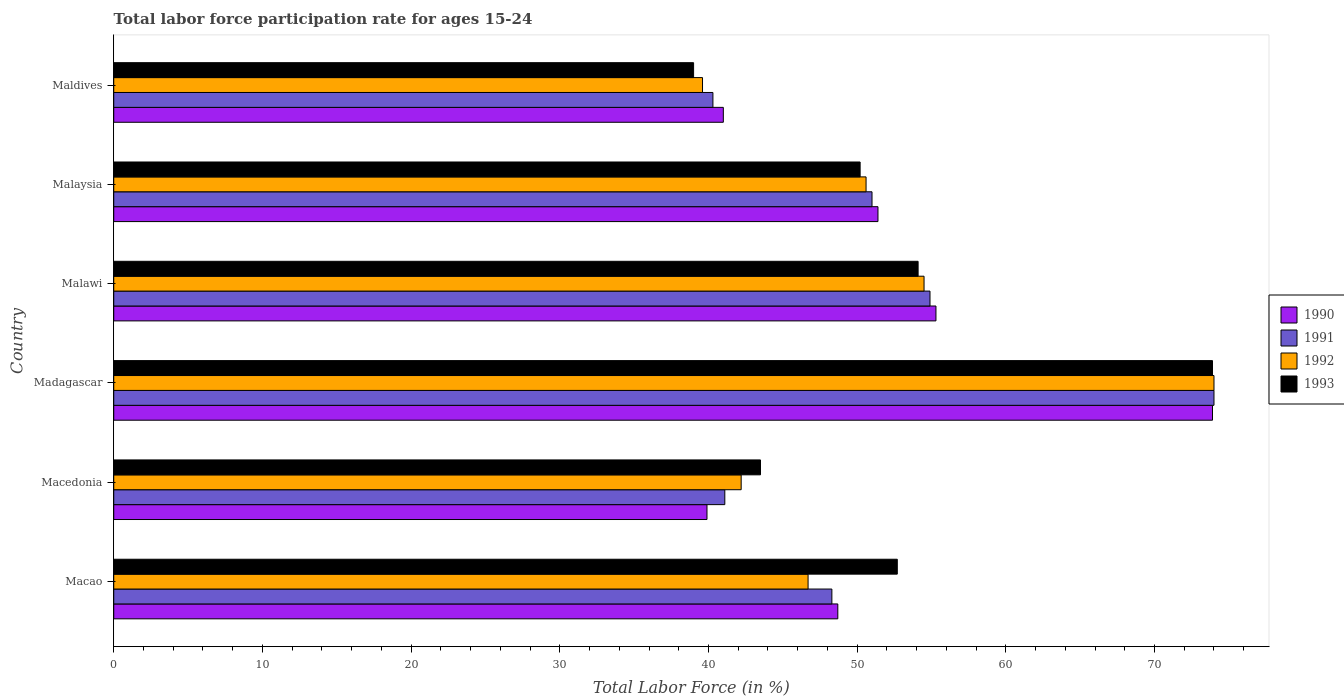Are the number of bars per tick equal to the number of legend labels?
Provide a short and direct response. Yes. Are the number of bars on each tick of the Y-axis equal?
Your answer should be compact. Yes. How many bars are there on the 6th tick from the top?
Your response must be concise. 4. What is the label of the 2nd group of bars from the top?
Give a very brief answer. Malaysia. In how many cases, is the number of bars for a given country not equal to the number of legend labels?
Provide a short and direct response. 0. What is the labor force participation rate in 1992 in Maldives?
Your response must be concise. 39.6. In which country was the labor force participation rate in 1993 maximum?
Give a very brief answer. Madagascar. In which country was the labor force participation rate in 1992 minimum?
Your answer should be compact. Maldives. What is the total labor force participation rate in 1993 in the graph?
Offer a terse response. 313.4. What is the difference between the labor force participation rate in 1991 in Madagascar and that in Maldives?
Make the answer very short. 33.7. What is the difference between the labor force participation rate in 1992 in Macao and the labor force participation rate in 1990 in Malawi?
Give a very brief answer. -8.6. What is the average labor force participation rate in 1993 per country?
Keep it short and to the point. 52.23. What is the difference between the labor force participation rate in 1991 and labor force participation rate in 1992 in Macao?
Offer a terse response. 1.6. What is the ratio of the labor force participation rate in 1992 in Macao to that in Madagascar?
Keep it short and to the point. 0.63. Is the labor force participation rate in 1993 in Macedonia less than that in Malawi?
Your response must be concise. Yes. Is the difference between the labor force participation rate in 1991 in Malawi and Malaysia greater than the difference between the labor force participation rate in 1992 in Malawi and Malaysia?
Give a very brief answer. No. What is the difference between the highest and the lowest labor force participation rate in 1993?
Offer a terse response. 34.9. In how many countries, is the labor force participation rate in 1991 greater than the average labor force participation rate in 1991 taken over all countries?
Your response must be concise. 2. Is the sum of the labor force participation rate in 1990 in Macedonia and Malaysia greater than the maximum labor force participation rate in 1993 across all countries?
Provide a succinct answer. Yes. What does the 4th bar from the top in Malawi represents?
Your answer should be very brief. 1990. Is it the case that in every country, the sum of the labor force participation rate in 1990 and labor force participation rate in 1992 is greater than the labor force participation rate in 1991?
Offer a very short reply. Yes. How many bars are there?
Provide a succinct answer. 24. How many countries are there in the graph?
Ensure brevity in your answer.  6. Are the values on the major ticks of X-axis written in scientific E-notation?
Offer a very short reply. No. Does the graph contain grids?
Give a very brief answer. No. Where does the legend appear in the graph?
Your answer should be very brief. Center right. How many legend labels are there?
Your response must be concise. 4. How are the legend labels stacked?
Keep it short and to the point. Vertical. What is the title of the graph?
Offer a very short reply. Total labor force participation rate for ages 15-24. Does "1962" appear as one of the legend labels in the graph?
Offer a terse response. No. What is the label or title of the Y-axis?
Make the answer very short. Country. What is the Total Labor Force (in %) of 1990 in Macao?
Ensure brevity in your answer.  48.7. What is the Total Labor Force (in %) of 1991 in Macao?
Provide a succinct answer. 48.3. What is the Total Labor Force (in %) of 1992 in Macao?
Keep it short and to the point. 46.7. What is the Total Labor Force (in %) of 1993 in Macao?
Ensure brevity in your answer.  52.7. What is the Total Labor Force (in %) in 1990 in Macedonia?
Provide a succinct answer. 39.9. What is the Total Labor Force (in %) of 1991 in Macedonia?
Ensure brevity in your answer.  41.1. What is the Total Labor Force (in %) in 1992 in Macedonia?
Your answer should be compact. 42.2. What is the Total Labor Force (in %) in 1993 in Macedonia?
Provide a short and direct response. 43.5. What is the Total Labor Force (in %) in 1990 in Madagascar?
Your answer should be very brief. 73.9. What is the Total Labor Force (in %) in 1993 in Madagascar?
Ensure brevity in your answer.  73.9. What is the Total Labor Force (in %) in 1990 in Malawi?
Make the answer very short. 55.3. What is the Total Labor Force (in %) in 1991 in Malawi?
Keep it short and to the point. 54.9. What is the Total Labor Force (in %) in 1992 in Malawi?
Make the answer very short. 54.5. What is the Total Labor Force (in %) in 1993 in Malawi?
Provide a succinct answer. 54.1. What is the Total Labor Force (in %) in 1990 in Malaysia?
Keep it short and to the point. 51.4. What is the Total Labor Force (in %) of 1991 in Malaysia?
Your answer should be compact. 51. What is the Total Labor Force (in %) in 1992 in Malaysia?
Your answer should be very brief. 50.6. What is the Total Labor Force (in %) in 1993 in Malaysia?
Your answer should be compact. 50.2. What is the Total Labor Force (in %) in 1990 in Maldives?
Your answer should be compact. 41. What is the Total Labor Force (in %) in 1991 in Maldives?
Your answer should be very brief. 40.3. What is the Total Labor Force (in %) of 1992 in Maldives?
Provide a short and direct response. 39.6. What is the Total Labor Force (in %) of 1993 in Maldives?
Keep it short and to the point. 39. Across all countries, what is the maximum Total Labor Force (in %) of 1990?
Your answer should be very brief. 73.9. Across all countries, what is the maximum Total Labor Force (in %) in 1993?
Give a very brief answer. 73.9. Across all countries, what is the minimum Total Labor Force (in %) in 1990?
Your response must be concise. 39.9. Across all countries, what is the minimum Total Labor Force (in %) of 1991?
Your answer should be compact. 40.3. Across all countries, what is the minimum Total Labor Force (in %) in 1992?
Make the answer very short. 39.6. Across all countries, what is the minimum Total Labor Force (in %) in 1993?
Provide a short and direct response. 39. What is the total Total Labor Force (in %) in 1990 in the graph?
Provide a succinct answer. 310.2. What is the total Total Labor Force (in %) in 1991 in the graph?
Your answer should be compact. 309.6. What is the total Total Labor Force (in %) in 1992 in the graph?
Provide a succinct answer. 307.6. What is the total Total Labor Force (in %) in 1993 in the graph?
Your response must be concise. 313.4. What is the difference between the Total Labor Force (in %) of 1993 in Macao and that in Macedonia?
Offer a terse response. 9.2. What is the difference between the Total Labor Force (in %) of 1990 in Macao and that in Madagascar?
Provide a short and direct response. -25.2. What is the difference between the Total Labor Force (in %) in 1991 in Macao and that in Madagascar?
Ensure brevity in your answer.  -25.7. What is the difference between the Total Labor Force (in %) in 1992 in Macao and that in Madagascar?
Your response must be concise. -27.3. What is the difference between the Total Labor Force (in %) in 1993 in Macao and that in Madagascar?
Your response must be concise. -21.2. What is the difference between the Total Labor Force (in %) in 1990 in Macao and that in Malawi?
Offer a very short reply. -6.6. What is the difference between the Total Labor Force (in %) of 1992 in Macao and that in Malawi?
Your answer should be very brief. -7.8. What is the difference between the Total Labor Force (in %) of 1991 in Macao and that in Malaysia?
Keep it short and to the point. -2.7. What is the difference between the Total Labor Force (in %) of 1992 in Macao and that in Malaysia?
Offer a terse response. -3.9. What is the difference between the Total Labor Force (in %) in 1993 in Macao and that in Malaysia?
Give a very brief answer. 2.5. What is the difference between the Total Labor Force (in %) of 1990 in Macao and that in Maldives?
Provide a short and direct response. 7.7. What is the difference between the Total Labor Force (in %) in 1991 in Macao and that in Maldives?
Ensure brevity in your answer.  8. What is the difference between the Total Labor Force (in %) of 1993 in Macao and that in Maldives?
Keep it short and to the point. 13.7. What is the difference between the Total Labor Force (in %) of 1990 in Macedonia and that in Madagascar?
Your response must be concise. -34. What is the difference between the Total Labor Force (in %) in 1991 in Macedonia and that in Madagascar?
Offer a very short reply. -32.9. What is the difference between the Total Labor Force (in %) in 1992 in Macedonia and that in Madagascar?
Your answer should be compact. -31.8. What is the difference between the Total Labor Force (in %) in 1993 in Macedonia and that in Madagascar?
Your answer should be compact. -30.4. What is the difference between the Total Labor Force (in %) in 1990 in Macedonia and that in Malawi?
Offer a very short reply. -15.4. What is the difference between the Total Labor Force (in %) in 1991 in Macedonia and that in Malawi?
Make the answer very short. -13.8. What is the difference between the Total Labor Force (in %) of 1992 in Macedonia and that in Malawi?
Offer a terse response. -12.3. What is the difference between the Total Labor Force (in %) in 1990 in Macedonia and that in Malaysia?
Provide a short and direct response. -11.5. What is the difference between the Total Labor Force (in %) of 1991 in Macedonia and that in Malaysia?
Offer a very short reply. -9.9. What is the difference between the Total Labor Force (in %) in 1990 in Macedonia and that in Maldives?
Your answer should be compact. -1.1. What is the difference between the Total Labor Force (in %) of 1991 in Macedonia and that in Maldives?
Your answer should be compact. 0.8. What is the difference between the Total Labor Force (in %) in 1992 in Macedonia and that in Maldives?
Your response must be concise. 2.6. What is the difference between the Total Labor Force (in %) of 1990 in Madagascar and that in Malawi?
Provide a short and direct response. 18.6. What is the difference between the Total Labor Force (in %) of 1993 in Madagascar and that in Malawi?
Give a very brief answer. 19.8. What is the difference between the Total Labor Force (in %) in 1992 in Madagascar and that in Malaysia?
Your answer should be very brief. 23.4. What is the difference between the Total Labor Force (in %) in 1993 in Madagascar and that in Malaysia?
Your answer should be compact. 23.7. What is the difference between the Total Labor Force (in %) in 1990 in Madagascar and that in Maldives?
Ensure brevity in your answer.  32.9. What is the difference between the Total Labor Force (in %) in 1991 in Madagascar and that in Maldives?
Your answer should be compact. 33.7. What is the difference between the Total Labor Force (in %) of 1992 in Madagascar and that in Maldives?
Provide a succinct answer. 34.4. What is the difference between the Total Labor Force (in %) of 1993 in Madagascar and that in Maldives?
Offer a very short reply. 34.9. What is the difference between the Total Labor Force (in %) in 1990 in Malawi and that in Malaysia?
Ensure brevity in your answer.  3.9. What is the difference between the Total Labor Force (in %) of 1991 in Malawi and that in Malaysia?
Provide a succinct answer. 3.9. What is the difference between the Total Labor Force (in %) of 1992 in Malawi and that in Malaysia?
Offer a very short reply. 3.9. What is the difference between the Total Labor Force (in %) of 1993 in Malawi and that in Malaysia?
Your response must be concise. 3.9. What is the difference between the Total Labor Force (in %) in 1991 in Malawi and that in Maldives?
Make the answer very short. 14.6. What is the difference between the Total Labor Force (in %) in 1993 in Malawi and that in Maldives?
Make the answer very short. 15.1. What is the difference between the Total Labor Force (in %) of 1990 in Malaysia and that in Maldives?
Give a very brief answer. 10.4. What is the difference between the Total Labor Force (in %) of 1992 in Malaysia and that in Maldives?
Offer a very short reply. 11. What is the difference between the Total Labor Force (in %) in 1990 in Macao and the Total Labor Force (in %) in 1993 in Macedonia?
Provide a succinct answer. 5.2. What is the difference between the Total Labor Force (in %) in 1992 in Macao and the Total Labor Force (in %) in 1993 in Macedonia?
Make the answer very short. 3.2. What is the difference between the Total Labor Force (in %) in 1990 in Macao and the Total Labor Force (in %) in 1991 in Madagascar?
Make the answer very short. -25.3. What is the difference between the Total Labor Force (in %) of 1990 in Macao and the Total Labor Force (in %) of 1992 in Madagascar?
Offer a terse response. -25.3. What is the difference between the Total Labor Force (in %) in 1990 in Macao and the Total Labor Force (in %) in 1993 in Madagascar?
Ensure brevity in your answer.  -25.2. What is the difference between the Total Labor Force (in %) of 1991 in Macao and the Total Labor Force (in %) of 1992 in Madagascar?
Your answer should be compact. -25.7. What is the difference between the Total Labor Force (in %) in 1991 in Macao and the Total Labor Force (in %) in 1993 in Madagascar?
Ensure brevity in your answer.  -25.6. What is the difference between the Total Labor Force (in %) in 1992 in Macao and the Total Labor Force (in %) in 1993 in Madagascar?
Provide a succinct answer. -27.2. What is the difference between the Total Labor Force (in %) in 1990 in Macao and the Total Labor Force (in %) in 1992 in Malawi?
Ensure brevity in your answer.  -5.8. What is the difference between the Total Labor Force (in %) of 1991 in Macao and the Total Labor Force (in %) of 1992 in Malawi?
Provide a short and direct response. -6.2. What is the difference between the Total Labor Force (in %) of 1992 in Macao and the Total Labor Force (in %) of 1993 in Malawi?
Give a very brief answer. -7.4. What is the difference between the Total Labor Force (in %) in 1990 in Macao and the Total Labor Force (in %) in 1991 in Malaysia?
Ensure brevity in your answer.  -2.3. What is the difference between the Total Labor Force (in %) in 1990 in Macao and the Total Labor Force (in %) in 1992 in Malaysia?
Offer a terse response. -1.9. What is the difference between the Total Labor Force (in %) in 1990 in Macao and the Total Labor Force (in %) in 1993 in Malaysia?
Offer a very short reply. -1.5. What is the difference between the Total Labor Force (in %) of 1990 in Macao and the Total Labor Force (in %) of 1991 in Maldives?
Make the answer very short. 8.4. What is the difference between the Total Labor Force (in %) of 1990 in Macao and the Total Labor Force (in %) of 1992 in Maldives?
Provide a short and direct response. 9.1. What is the difference between the Total Labor Force (in %) in 1991 in Macao and the Total Labor Force (in %) in 1992 in Maldives?
Your answer should be compact. 8.7. What is the difference between the Total Labor Force (in %) in 1992 in Macao and the Total Labor Force (in %) in 1993 in Maldives?
Give a very brief answer. 7.7. What is the difference between the Total Labor Force (in %) of 1990 in Macedonia and the Total Labor Force (in %) of 1991 in Madagascar?
Your answer should be very brief. -34.1. What is the difference between the Total Labor Force (in %) in 1990 in Macedonia and the Total Labor Force (in %) in 1992 in Madagascar?
Provide a short and direct response. -34.1. What is the difference between the Total Labor Force (in %) in 1990 in Macedonia and the Total Labor Force (in %) in 1993 in Madagascar?
Your answer should be compact. -34. What is the difference between the Total Labor Force (in %) of 1991 in Macedonia and the Total Labor Force (in %) of 1992 in Madagascar?
Make the answer very short. -32.9. What is the difference between the Total Labor Force (in %) in 1991 in Macedonia and the Total Labor Force (in %) in 1993 in Madagascar?
Give a very brief answer. -32.8. What is the difference between the Total Labor Force (in %) in 1992 in Macedonia and the Total Labor Force (in %) in 1993 in Madagascar?
Offer a terse response. -31.7. What is the difference between the Total Labor Force (in %) of 1990 in Macedonia and the Total Labor Force (in %) of 1991 in Malawi?
Offer a terse response. -15. What is the difference between the Total Labor Force (in %) in 1990 in Macedonia and the Total Labor Force (in %) in 1992 in Malawi?
Give a very brief answer. -14.6. What is the difference between the Total Labor Force (in %) of 1991 in Macedonia and the Total Labor Force (in %) of 1993 in Malawi?
Offer a very short reply. -13. What is the difference between the Total Labor Force (in %) in 1990 in Macedonia and the Total Labor Force (in %) in 1993 in Malaysia?
Make the answer very short. -10.3. What is the difference between the Total Labor Force (in %) of 1991 in Macedonia and the Total Labor Force (in %) of 1992 in Malaysia?
Offer a terse response. -9.5. What is the difference between the Total Labor Force (in %) in 1990 in Macedonia and the Total Labor Force (in %) in 1993 in Maldives?
Your answer should be compact. 0.9. What is the difference between the Total Labor Force (in %) in 1991 in Macedonia and the Total Labor Force (in %) in 1992 in Maldives?
Offer a very short reply. 1.5. What is the difference between the Total Labor Force (in %) of 1991 in Macedonia and the Total Labor Force (in %) of 1993 in Maldives?
Provide a succinct answer. 2.1. What is the difference between the Total Labor Force (in %) in 1990 in Madagascar and the Total Labor Force (in %) in 1992 in Malawi?
Keep it short and to the point. 19.4. What is the difference between the Total Labor Force (in %) of 1990 in Madagascar and the Total Labor Force (in %) of 1993 in Malawi?
Your answer should be very brief. 19.8. What is the difference between the Total Labor Force (in %) in 1990 in Madagascar and the Total Labor Force (in %) in 1991 in Malaysia?
Keep it short and to the point. 22.9. What is the difference between the Total Labor Force (in %) in 1990 in Madagascar and the Total Labor Force (in %) in 1992 in Malaysia?
Offer a terse response. 23.3. What is the difference between the Total Labor Force (in %) in 1990 in Madagascar and the Total Labor Force (in %) in 1993 in Malaysia?
Your answer should be very brief. 23.7. What is the difference between the Total Labor Force (in %) of 1991 in Madagascar and the Total Labor Force (in %) of 1992 in Malaysia?
Give a very brief answer. 23.4. What is the difference between the Total Labor Force (in %) in 1991 in Madagascar and the Total Labor Force (in %) in 1993 in Malaysia?
Give a very brief answer. 23.8. What is the difference between the Total Labor Force (in %) in 1992 in Madagascar and the Total Labor Force (in %) in 1993 in Malaysia?
Your response must be concise. 23.8. What is the difference between the Total Labor Force (in %) of 1990 in Madagascar and the Total Labor Force (in %) of 1991 in Maldives?
Provide a short and direct response. 33.6. What is the difference between the Total Labor Force (in %) in 1990 in Madagascar and the Total Labor Force (in %) in 1992 in Maldives?
Your answer should be compact. 34.3. What is the difference between the Total Labor Force (in %) in 1990 in Madagascar and the Total Labor Force (in %) in 1993 in Maldives?
Keep it short and to the point. 34.9. What is the difference between the Total Labor Force (in %) in 1991 in Madagascar and the Total Labor Force (in %) in 1992 in Maldives?
Give a very brief answer. 34.4. What is the difference between the Total Labor Force (in %) in 1990 in Malawi and the Total Labor Force (in %) in 1992 in Malaysia?
Make the answer very short. 4.7. What is the difference between the Total Labor Force (in %) in 1991 in Malawi and the Total Labor Force (in %) in 1992 in Malaysia?
Give a very brief answer. 4.3. What is the difference between the Total Labor Force (in %) of 1991 in Malawi and the Total Labor Force (in %) of 1993 in Malaysia?
Give a very brief answer. 4.7. What is the difference between the Total Labor Force (in %) in 1990 in Malawi and the Total Labor Force (in %) in 1992 in Maldives?
Provide a short and direct response. 15.7. What is the difference between the Total Labor Force (in %) in 1991 in Malawi and the Total Labor Force (in %) in 1993 in Maldives?
Provide a succinct answer. 15.9. What is the difference between the Total Labor Force (in %) in 1992 in Malawi and the Total Labor Force (in %) in 1993 in Maldives?
Offer a very short reply. 15.5. What is the difference between the Total Labor Force (in %) in 1990 in Malaysia and the Total Labor Force (in %) in 1992 in Maldives?
Provide a succinct answer. 11.8. What is the difference between the Total Labor Force (in %) of 1991 in Malaysia and the Total Labor Force (in %) of 1992 in Maldives?
Your answer should be very brief. 11.4. What is the average Total Labor Force (in %) of 1990 per country?
Your response must be concise. 51.7. What is the average Total Labor Force (in %) in 1991 per country?
Make the answer very short. 51.6. What is the average Total Labor Force (in %) of 1992 per country?
Offer a terse response. 51.27. What is the average Total Labor Force (in %) of 1993 per country?
Ensure brevity in your answer.  52.23. What is the difference between the Total Labor Force (in %) in 1990 and Total Labor Force (in %) in 1991 in Macao?
Give a very brief answer. 0.4. What is the difference between the Total Labor Force (in %) in 1990 and Total Labor Force (in %) in 1992 in Macao?
Make the answer very short. 2. What is the difference between the Total Labor Force (in %) of 1990 and Total Labor Force (in %) of 1993 in Macao?
Offer a terse response. -4. What is the difference between the Total Labor Force (in %) in 1991 and Total Labor Force (in %) in 1992 in Macao?
Provide a succinct answer. 1.6. What is the difference between the Total Labor Force (in %) in 1991 and Total Labor Force (in %) in 1993 in Macao?
Provide a short and direct response. -4.4. What is the difference between the Total Labor Force (in %) of 1991 and Total Labor Force (in %) of 1992 in Macedonia?
Give a very brief answer. -1.1. What is the difference between the Total Labor Force (in %) of 1990 and Total Labor Force (in %) of 1992 in Madagascar?
Make the answer very short. -0.1. What is the difference between the Total Labor Force (in %) of 1990 and Total Labor Force (in %) of 1993 in Madagascar?
Offer a very short reply. 0. What is the difference between the Total Labor Force (in %) of 1991 and Total Labor Force (in %) of 1993 in Madagascar?
Give a very brief answer. 0.1. What is the difference between the Total Labor Force (in %) in 1990 and Total Labor Force (in %) in 1993 in Malawi?
Provide a succinct answer. 1.2. What is the difference between the Total Labor Force (in %) in 1990 and Total Labor Force (in %) in 1991 in Malaysia?
Your response must be concise. 0.4. What is the difference between the Total Labor Force (in %) of 1992 and Total Labor Force (in %) of 1993 in Malaysia?
Ensure brevity in your answer.  0.4. What is the difference between the Total Labor Force (in %) in 1991 and Total Labor Force (in %) in 1992 in Maldives?
Provide a short and direct response. 0.7. What is the difference between the Total Labor Force (in %) of 1991 and Total Labor Force (in %) of 1993 in Maldives?
Offer a terse response. 1.3. What is the ratio of the Total Labor Force (in %) of 1990 in Macao to that in Macedonia?
Offer a very short reply. 1.22. What is the ratio of the Total Labor Force (in %) of 1991 in Macao to that in Macedonia?
Offer a terse response. 1.18. What is the ratio of the Total Labor Force (in %) in 1992 in Macao to that in Macedonia?
Make the answer very short. 1.11. What is the ratio of the Total Labor Force (in %) of 1993 in Macao to that in Macedonia?
Your response must be concise. 1.21. What is the ratio of the Total Labor Force (in %) of 1990 in Macao to that in Madagascar?
Ensure brevity in your answer.  0.66. What is the ratio of the Total Labor Force (in %) of 1991 in Macao to that in Madagascar?
Provide a short and direct response. 0.65. What is the ratio of the Total Labor Force (in %) of 1992 in Macao to that in Madagascar?
Offer a terse response. 0.63. What is the ratio of the Total Labor Force (in %) in 1993 in Macao to that in Madagascar?
Your answer should be very brief. 0.71. What is the ratio of the Total Labor Force (in %) in 1990 in Macao to that in Malawi?
Make the answer very short. 0.88. What is the ratio of the Total Labor Force (in %) in 1991 in Macao to that in Malawi?
Provide a short and direct response. 0.88. What is the ratio of the Total Labor Force (in %) in 1992 in Macao to that in Malawi?
Offer a terse response. 0.86. What is the ratio of the Total Labor Force (in %) in 1993 in Macao to that in Malawi?
Your answer should be very brief. 0.97. What is the ratio of the Total Labor Force (in %) of 1990 in Macao to that in Malaysia?
Ensure brevity in your answer.  0.95. What is the ratio of the Total Labor Force (in %) of 1991 in Macao to that in Malaysia?
Offer a very short reply. 0.95. What is the ratio of the Total Labor Force (in %) in 1992 in Macao to that in Malaysia?
Give a very brief answer. 0.92. What is the ratio of the Total Labor Force (in %) in 1993 in Macao to that in Malaysia?
Provide a succinct answer. 1.05. What is the ratio of the Total Labor Force (in %) in 1990 in Macao to that in Maldives?
Ensure brevity in your answer.  1.19. What is the ratio of the Total Labor Force (in %) of 1991 in Macao to that in Maldives?
Give a very brief answer. 1.2. What is the ratio of the Total Labor Force (in %) of 1992 in Macao to that in Maldives?
Make the answer very short. 1.18. What is the ratio of the Total Labor Force (in %) in 1993 in Macao to that in Maldives?
Offer a very short reply. 1.35. What is the ratio of the Total Labor Force (in %) of 1990 in Macedonia to that in Madagascar?
Make the answer very short. 0.54. What is the ratio of the Total Labor Force (in %) in 1991 in Macedonia to that in Madagascar?
Give a very brief answer. 0.56. What is the ratio of the Total Labor Force (in %) of 1992 in Macedonia to that in Madagascar?
Give a very brief answer. 0.57. What is the ratio of the Total Labor Force (in %) of 1993 in Macedonia to that in Madagascar?
Provide a short and direct response. 0.59. What is the ratio of the Total Labor Force (in %) in 1990 in Macedonia to that in Malawi?
Make the answer very short. 0.72. What is the ratio of the Total Labor Force (in %) in 1991 in Macedonia to that in Malawi?
Your answer should be very brief. 0.75. What is the ratio of the Total Labor Force (in %) in 1992 in Macedonia to that in Malawi?
Your answer should be very brief. 0.77. What is the ratio of the Total Labor Force (in %) in 1993 in Macedonia to that in Malawi?
Provide a short and direct response. 0.8. What is the ratio of the Total Labor Force (in %) in 1990 in Macedonia to that in Malaysia?
Your response must be concise. 0.78. What is the ratio of the Total Labor Force (in %) of 1991 in Macedonia to that in Malaysia?
Your response must be concise. 0.81. What is the ratio of the Total Labor Force (in %) in 1992 in Macedonia to that in Malaysia?
Provide a short and direct response. 0.83. What is the ratio of the Total Labor Force (in %) of 1993 in Macedonia to that in Malaysia?
Your answer should be very brief. 0.87. What is the ratio of the Total Labor Force (in %) of 1990 in Macedonia to that in Maldives?
Your answer should be very brief. 0.97. What is the ratio of the Total Labor Force (in %) of 1991 in Macedonia to that in Maldives?
Provide a short and direct response. 1.02. What is the ratio of the Total Labor Force (in %) in 1992 in Macedonia to that in Maldives?
Your answer should be compact. 1.07. What is the ratio of the Total Labor Force (in %) in 1993 in Macedonia to that in Maldives?
Keep it short and to the point. 1.12. What is the ratio of the Total Labor Force (in %) of 1990 in Madagascar to that in Malawi?
Provide a short and direct response. 1.34. What is the ratio of the Total Labor Force (in %) of 1991 in Madagascar to that in Malawi?
Keep it short and to the point. 1.35. What is the ratio of the Total Labor Force (in %) in 1992 in Madagascar to that in Malawi?
Provide a short and direct response. 1.36. What is the ratio of the Total Labor Force (in %) of 1993 in Madagascar to that in Malawi?
Your answer should be compact. 1.37. What is the ratio of the Total Labor Force (in %) of 1990 in Madagascar to that in Malaysia?
Offer a very short reply. 1.44. What is the ratio of the Total Labor Force (in %) in 1991 in Madagascar to that in Malaysia?
Keep it short and to the point. 1.45. What is the ratio of the Total Labor Force (in %) of 1992 in Madagascar to that in Malaysia?
Keep it short and to the point. 1.46. What is the ratio of the Total Labor Force (in %) in 1993 in Madagascar to that in Malaysia?
Offer a terse response. 1.47. What is the ratio of the Total Labor Force (in %) of 1990 in Madagascar to that in Maldives?
Your answer should be very brief. 1.8. What is the ratio of the Total Labor Force (in %) of 1991 in Madagascar to that in Maldives?
Give a very brief answer. 1.84. What is the ratio of the Total Labor Force (in %) in 1992 in Madagascar to that in Maldives?
Keep it short and to the point. 1.87. What is the ratio of the Total Labor Force (in %) in 1993 in Madagascar to that in Maldives?
Keep it short and to the point. 1.89. What is the ratio of the Total Labor Force (in %) in 1990 in Malawi to that in Malaysia?
Keep it short and to the point. 1.08. What is the ratio of the Total Labor Force (in %) in 1991 in Malawi to that in Malaysia?
Your response must be concise. 1.08. What is the ratio of the Total Labor Force (in %) of 1992 in Malawi to that in Malaysia?
Your response must be concise. 1.08. What is the ratio of the Total Labor Force (in %) of 1993 in Malawi to that in Malaysia?
Offer a very short reply. 1.08. What is the ratio of the Total Labor Force (in %) in 1990 in Malawi to that in Maldives?
Offer a terse response. 1.35. What is the ratio of the Total Labor Force (in %) of 1991 in Malawi to that in Maldives?
Your response must be concise. 1.36. What is the ratio of the Total Labor Force (in %) of 1992 in Malawi to that in Maldives?
Keep it short and to the point. 1.38. What is the ratio of the Total Labor Force (in %) of 1993 in Malawi to that in Maldives?
Offer a very short reply. 1.39. What is the ratio of the Total Labor Force (in %) in 1990 in Malaysia to that in Maldives?
Provide a short and direct response. 1.25. What is the ratio of the Total Labor Force (in %) of 1991 in Malaysia to that in Maldives?
Offer a very short reply. 1.27. What is the ratio of the Total Labor Force (in %) of 1992 in Malaysia to that in Maldives?
Keep it short and to the point. 1.28. What is the ratio of the Total Labor Force (in %) in 1993 in Malaysia to that in Maldives?
Keep it short and to the point. 1.29. What is the difference between the highest and the second highest Total Labor Force (in %) in 1990?
Give a very brief answer. 18.6. What is the difference between the highest and the second highest Total Labor Force (in %) of 1993?
Ensure brevity in your answer.  19.8. What is the difference between the highest and the lowest Total Labor Force (in %) of 1991?
Make the answer very short. 33.7. What is the difference between the highest and the lowest Total Labor Force (in %) in 1992?
Provide a succinct answer. 34.4. What is the difference between the highest and the lowest Total Labor Force (in %) in 1993?
Your answer should be very brief. 34.9. 